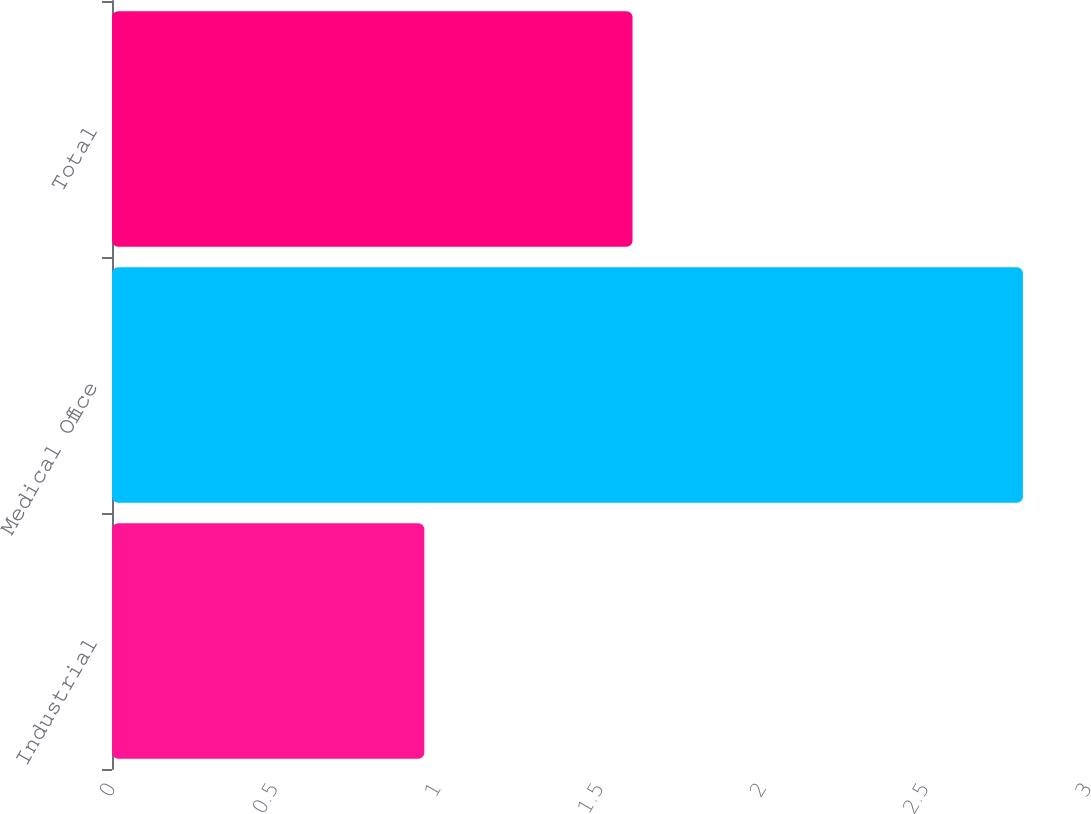Convert chart. <chart><loc_0><loc_0><loc_500><loc_500><bar_chart><fcel>Industrial<fcel>Medical Office<fcel>Total<nl><fcel>0.96<fcel>2.8<fcel>1.6<nl></chart> 